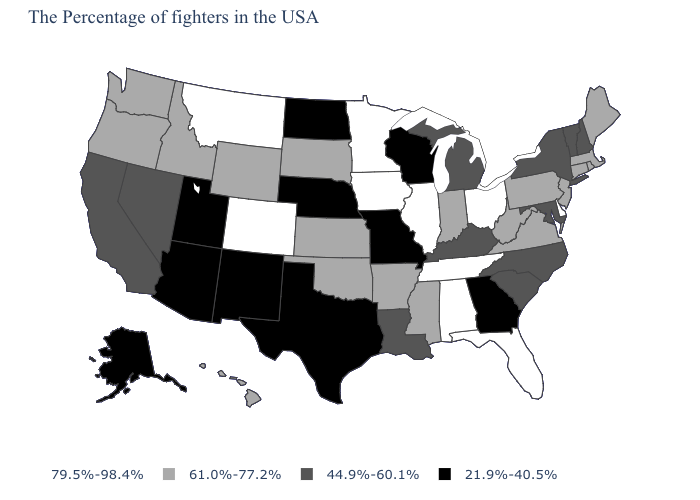Name the states that have a value in the range 79.5%-98.4%?
Concise answer only. Delaware, Ohio, Florida, Alabama, Tennessee, Illinois, Minnesota, Iowa, Colorado, Montana. Name the states that have a value in the range 61.0%-77.2%?
Short answer required. Maine, Massachusetts, Rhode Island, Connecticut, New Jersey, Pennsylvania, Virginia, West Virginia, Indiana, Mississippi, Arkansas, Kansas, Oklahoma, South Dakota, Wyoming, Idaho, Washington, Oregon, Hawaii. What is the value of Nebraska?
Concise answer only. 21.9%-40.5%. What is the value of New Mexico?
Concise answer only. 21.9%-40.5%. Name the states that have a value in the range 21.9%-40.5%?
Be succinct. Georgia, Wisconsin, Missouri, Nebraska, Texas, North Dakota, New Mexico, Utah, Arizona, Alaska. Does Rhode Island have the highest value in the Northeast?
Concise answer only. Yes. Name the states that have a value in the range 79.5%-98.4%?
Concise answer only. Delaware, Ohio, Florida, Alabama, Tennessee, Illinois, Minnesota, Iowa, Colorado, Montana. Does Alabama have the highest value in the South?
Answer briefly. Yes. Name the states that have a value in the range 61.0%-77.2%?
Concise answer only. Maine, Massachusetts, Rhode Island, Connecticut, New Jersey, Pennsylvania, Virginia, West Virginia, Indiana, Mississippi, Arkansas, Kansas, Oklahoma, South Dakota, Wyoming, Idaho, Washington, Oregon, Hawaii. What is the highest value in states that border Wisconsin?
Give a very brief answer. 79.5%-98.4%. Does the first symbol in the legend represent the smallest category?
Keep it brief. No. Which states hav the highest value in the Northeast?
Short answer required. Maine, Massachusetts, Rhode Island, Connecticut, New Jersey, Pennsylvania. Does Maryland have a lower value than Alaska?
Be succinct. No. What is the value of Michigan?
Short answer required. 44.9%-60.1%. Among the states that border Tennessee , which have the lowest value?
Give a very brief answer. Georgia, Missouri. 